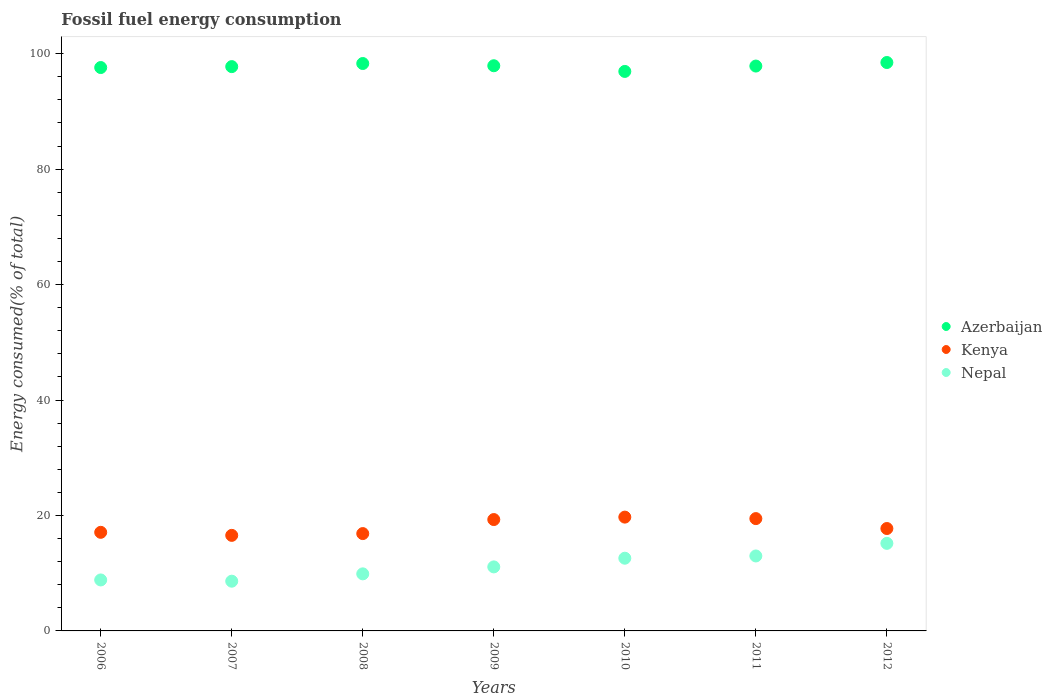Is the number of dotlines equal to the number of legend labels?
Make the answer very short. Yes. What is the percentage of energy consumed in Kenya in 2009?
Ensure brevity in your answer.  19.29. Across all years, what is the maximum percentage of energy consumed in Nepal?
Offer a terse response. 15.17. Across all years, what is the minimum percentage of energy consumed in Kenya?
Offer a very short reply. 16.55. In which year was the percentage of energy consumed in Kenya maximum?
Make the answer very short. 2010. In which year was the percentage of energy consumed in Azerbaijan minimum?
Your answer should be compact. 2010. What is the total percentage of energy consumed in Azerbaijan in the graph?
Ensure brevity in your answer.  684.86. What is the difference between the percentage of energy consumed in Kenya in 2006 and that in 2012?
Ensure brevity in your answer.  -0.66. What is the difference between the percentage of energy consumed in Nepal in 2008 and the percentage of energy consumed in Kenya in 2009?
Offer a very short reply. -9.41. What is the average percentage of energy consumed in Kenya per year?
Your answer should be compact. 18.1. In the year 2006, what is the difference between the percentage of energy consumed in Nepal and percentage of energy consumed in Kenya?
Offer a terse response. -8.25. What is the ratio of the percentage of energy consumed in Nepal in 2010 to that in 2011?
Offer a terse response. 0.97. Is the percentage of energy consumed in Azerbaijan in 2007 less than that in 2012?
Your answer should be compact. Yes. Is the difference between the percentage of energy consumed in Nepal in 2010 and 2012 greater than the difference between the percentage of energy consumed in Kenya in 2010 and 2012?
Your answer should be very brief. No. What is the difference between the highest and the second highest percentage of energy consumed in Azerbaijan?
Offer a very short reply. 0.17. What is the difference between the highest and the lowest percentage of energy consumed in Nepal?
Make the answer very short. 6.56. In how many years, is the percentage of energy consumed in Kenya greater than the average percentage of energy consumed in Kenya taken over all years?
Make the answer very short. 3. Is the sum of the percentage of energy consumed in Azerbaijan in 2008 and 2010 greater than the maximum percentage of energy consumed in Kenya across all years?
Your response must be concise. Yes. Is it the case that in every year, the sum of the percentage of energy consumed in Azerbaijan and percentage of energy consumed in Nepal  is greater than the percentage of energy consumed in Kenya?
Provide a short and direct response. Yes. Is the percentage of energy consumed in Azerbaijan strictly less than the percentage of energy consumed in Kenya over the years?
Keep it short and to the point. No. How many years are there in the graph?
Offer a terse response. 7. Does the graph contain grids?
Your response must be concise. No. How are the legend labels stacked?
Provide a succinct answer. Vertical. What is the title of the graph?
Your answer should be very brief. Fossil fuel energy consumption. Does "Benin" appear as one of the legend labels in the graph?
Offer a terse response. No. What is the label or title of the Y-axis?
Your answer should be very brief. Energy consumed(% of total). What is the Energy consumed(% of total) in Azerbaijan in 2006?
Offer a terse response. 97.61. What is the Energy consumed(% of total) in Kenya in 2006?
Offer a very short reply. 17.08. What is the Energy consumed(% of total) in Nepal in 2006?
Your answer should be very brief. 8.83. What is the Energy consumed(% of total) of Azerbaijan in 2007?
Your response must be concise. 97.76. What is the Energy consumed(% of total) of Kenya in 2007?
Provide a succinct answer. 16.55. What is the Energy consumed(% of total) of Nepal in 2007?
Offer a terse response. 8.62. What is the Energy consumed(% of total) of Azerbaijan in 2008?
Your response must be concise. 98.3. What is the Energy consumed(% of total) of Kenya in 2008?
Keep it short and to the point. 16.86. What is the Energy consumed(% of total) in Nepal in 2008?
Your response must be concise. 9.89. What is the Energy consumed(% of total) in Azerbaijan in 2009?
Ensure brevity in your answer.  97.92. What is the Energy consumed(% of total) of Kenya in 2009?
Provide a succinct answer. 19.29. What is the Energy consumed(% of total) in Nepal in 2009?
Your answer should be very brief. 11.09. What is the Energy consumed(% of total) of Azerbaijan in 2010?
Provide a succinct answer. 96.93. What is the Energy consumed(% of total) of Kenya in 2010?
Offer a very short reply. 19.72. What is the Energy consumed(% of total) in Nepal in 2010?
Keep it short and to the point. 12.6. What is the Energy consumed(% of total) of Azerbaijan in 2011?
Make the answer very short. 97.86. What is the Energy consumed(% of total) of Kenya in 2011?
Your answer should be very brief. 19.46. What is the Energy consumed(% of total) of Nepal in 2011?
Keep it short and to the point. 12.99. What is the Energy consumed(% of total) of Azerbaijan in 2012?
Provide a short and direct response. 98.48. What is the Energy consumed(% of total) in Kenya in 2012?
Offer a very short reply. 17.74. What is the Energy consumed(% of total) in Nepal in 2012?
Keep it short and to the point. 15.17. Across all years, what is the maximum Energy consumed(% of total) of Azerbaijan?
Keep it short and to the point. 98.48. Across all years, what is the maximum Energy consumed(% of total) of Kenya?
Your response must be concise. 19.72. Across all years, what is the maximum Energy consumed(% of total) in Nepal?
Offer a terse response. 15.17. Across all years, what is the minimum Energy consumed(% of total) in Azerbaijan?
Ensure brevity in your answer.  96.93. Across all years, what is the minimum Energy consumed(% of total) in Kenya?
Offer a terse response. 16.55. Across all years, what is the minimum Energy consumed(% of total) of Nepal?
Give a very brief answer. 8.62. What is the total Energy consumed(% of total) in Azerbaijan in the graph?
Provide a short and direct response. 684.86. What is the total Energy consumed(% of total) in Kenya in the graph?
Keep it short and to the point. 126.71. What is the total Energy consumed(% of total) in Nepal in the graph?
Give a very brief answer. 79.18. What is the difference between the Energy consumed(% of total) in Azerbaijan in 2006 and that in 2007?
Make the answer very short. -0.16. What is the difference between the Energy consumed(% of total) in Kenya in 2006 and that in 2007?
Make the answer very short. 0.53. What is the difference between the Energy consumed(% of total) in Nepal in 2006 and that in 2007?
Keep it short and to the point. 0.22. What is the difference between the Energy consumed(% of total) of Azerbaijan in 2006 and that in 2008?
Offer a very short reply. -0.7. What is the difference between the Energy consumed(% of total) of Kenya in 2006 and that in 2008?
Offer a very short reply. 0.22. What is the difference between the Energy consumed(% of total) of Nepal in 2006 and that in 2008?
Ensure brevity in your answer.  -1.05. What is the difference between the Energy consumed(% of total) in Azerbaijan in 2006 and that in 2009?
Keep it short and to the point. -0.31. What is the difference between the Energy consumed(% of total) of Kenya in 2006 and that in 2009?
Your response must be concise. -2.21. What is the difference between the Energy consumed(% of total) of Nepal in 2006 and that in 2009?
Give a very brief answer. -2.26. What is the difference between the Energy consumed(% of total) in Azerbaijan in 2006 and that in 2010?
Ensure brevity in your answer.  0.67. What is the difference between the Energy consumed(% of total) of Kenya in 2006 and that in 2010?
Ensure brevity in your answer.  -2.63. What is the difference between the Energy consumed(% of total) in Nepal in 2006 and that in 2010?
Offer a terse response. -3.77. What is the difference between the Energy consumed(% of total) of Azerbaijan in 2006 and that in 2011?
Give a very brief answer. -0.26. What is the difference between the Energy consumed(% of total) of Kenya in 2006 and that in 2011?
Your answer should be very brief. -2.38. What is the difference between the Energy consumed(% of total) in Nepal in 2006 and that in 2011?
Make the answer very short. -4.16. What is the difference between the Energy consumed(% of total) in Azerbaijan in 2006 and that in 2012?
Offer a terse response. -0.87. What is the difference between the Energy consumed(% of total) in Kenya in 2006 and that in 2012?
Offer a terse response. -0.66. What is the difference between the Energy consumed(% of total) of Nepal in 2006 and that in 2012?
Offer a very short reply. -6.34. What is the difference between the Energy consumed(% of total) of Azerbaijan in 2007 and that in 2008?
Keep it short and to the point. -0.54. What is the difference between the Energy consumed(% of total) of Kenya in 2007 and that in 2008?
Offer a terse response. -0.31. What is the difference between the Energy consumed(% of total) in Nepal in 2007 and that in 2008?
Your response must be concise. -1.27. What is the difference between the Energy consumed(% of total) in Azerbaijan in 2007 and that in 2009?
Provide a short and direct response. -0.15. What is the difference between the Energy consumed(% of total) in Kenya in 2007 and that in 2009?
Your answer should be compact. -2.74. What is the difference between the Energy consumed(% of total) of Nepal in 2007 and that in 2009?
Your answer should be very brief. -2.48. What is the difference between the Energy consumed(% of total) in Azerbaijan in 2007 and that in 2010?
Keep it short and to the point. 0.83. What is the difference between the Energy consumed(% of total) in Kenya in 2007 and that in 2010?
Your response must be concise. -3.16. What is the difference between the Energy consumed(% of total) in Nepal in 2007 and that in 2010?
Provide a succinct answer. -3.98. What is the difference between the Energy consumed(% of total) in Azerbaijan in 2007 and that in 2011?
Keep it short and to the point. -0.1. What is the difference between the Energy consumed(% of total) of Kenya in 2007 and that in 2011?
Ensure brevity in your answer.  -2.91. What is the difference between the Energy consumed(% of total) of Nepal in 2007 and that in 2011?
Ensure brevity in your answer.  -4.37. What is the difference between the Energy consumed(% of total) in Azerbaijan in 2007 and that in 2012?
Offer a very short reply. -0.71. What is the difference between the Energy consumed(% of total) of Kenya in 2007 and that in 2012?
Provide a succinct answer. -1.19. What is the difference between the Energy consumed(% of total) of Nepal in 2007 and that in 2012?
Offer a terse response. -6.56. What is the difference between the Energy consumed(% of total) in Azerbaijan in 2008 and that in 2009?
Offer a very short reply. 0.39. What is the difference between the Energy consumed(% of total) of Kenya in 2008 and that in 2009?
Offer a terse response. -2.43. What is the difference between the Energy consumed(% of total) in Nepal in 2008 and that in 2009?
Offer a very short reply. -1.21. What is the difference between the Energy consumed(% of total) of Azerbaijan in 2008 and that in 2010?
Provide a short and direct response. 1.37. What is the difference between the Energy consumed(% of total) of Kenya in 2008 and that in 2010?
Keep it short and to the point. -2.85. What is the difference between the Energy consumed(% of total) in Nepal in 2008 and that in 2010?
Offer a terse response. -2.71. What is the difference between the Energy consumed(% of total) of Azerbaijan in 2008 and that in 2011?
Your answer should be very brief. 0.44. What is the difference between the Energy consumed(% of total) of Kenya in 2008 and that in 2011?
Make the answer very short. -2.6. What is the difference between the Energy consumed(% of total) in Nepal in 2008 and that in 2011?
Make the answer very short. -3.1. What is the difference between the Energy consumed(% of total) of Azerbaijan in 2008 and that in 2012?
Offer a terse response. -0.17. What is the difference between the Energy consumed(% of total) of Kenya in 2008 and that in 2012?
Offer a terse response. -0.88. What is the difference between the Energy consumed(% of total) of Nepal in 2008 and that in 2012?
Your answer should be compact. -5.28. What is the difference between the Energy consumed(% of total) of Azerbaijan in 2009 and that in 2010?
Your answer should be very brief. 0.98. What is the difference between the Energy consumed(% of total) of Kenya in 2009 and that in 2010?
Your answer should be very brief. -0.42. What is the difference between the Energy consumed(% of total) of Nepal in 2009 and that in 2010?
Offer a terse response. -1.5. What is the difference between the Energy consumed(% of total) in Azerbaijan in 2009 and that in 2011?
Offer a very short reply. 0.05. What is the difference between the Energy consumed(% of total) in Kenya in 2009 and that in 2011?
Offer a terse response. -0.16. What is the difference between the Energy consumed(% of total) in Nepal in 2009 and that in 2011?
Make the answer very short. -1.89. What is the difference between the Energy consumed(% of total) of Azerbaijan in 2009 and that in 2012?
Your response must be concise. -0.56. What is the difference between the Energy consumed(% of total) in Kenya in 2009 and that in 2012?
Provide a short and direct response. 1.55. What is the difference between the Energy consumed(% of total) in Nepal in 2009 and that in 2012?
Your answer should be compact. -4.08. What is the difference between the Energy consumed(% of total) in Azerbaijan in 2010 and that in 2011?
Your answer should be compact. -0.93. What is the difference between the Energy consumed(% of total) in Kenya in 2010 and that in 2011?
Your answer should be very brief. 0.26. What is the difference between the Energy consumed(% of total) of Nepal in 2010 and that in 2011?
Your answer should be very brief. -0.39. What is the difference between the Energy consumed(% of total) in Azerbaijan in 2010 and that in 2012?
Provide a short and direct response. -1.54. What is the difference between the Energy consumed(% of total) of Kenya in 2010 and that in 2012?
Provide a succinct answer. 1.97. What is the difference between the Energy consumed(% of total) in Nepal in 2010 and that in 2012?
Offer a terse response. -2.57. What is the difference between the Energy consumed(% of total) of Azerbaijan in 2011 and that in 2012?
Keep it short and to the point. -0.61. What is the difference between the Energy consumed(% of total) of Kenya in 2011 and that in 2012?
Provide a short and direct response. 1.72. What is the difference between the Energy consumed(% of total) of Nepal in 2011 and that in 2012?
Provide a short and direct response. -2.18. What is the difference between the Energy consumed(% of total) of Azerbaijan in 2006 and the Energy consumed(% of total) of Kenya in 2007?
Keep it short and to the point. 81.05. What is the difference between the Energy consumed(% of total) of Azerbaijan in 2006 and the Energy consumed(% of total) of Nepal in 2007?
Keep it short and to the point. 88.99. What is the difference between the Energy consumed(% of total) of Kenya in 2006 and the Energy consumed(% of total) of Nepal in 2007?
Provide a succinct answer. 8.47. What is the difference between the Energy consumed(% of total) in Azerbaijan in 2006 and the Energy consumed(% of total) in Kenya in 2008?
Your response must be concise. 80.74. What is the difference between the Energy consumed(% of total) in Azerbaijan in 2006 and the Energy consumed(% of total) in Nepal in 2008?
Keep it short and to the point. 87.72. What is the difference between the Energy consumed(% of total) in Kenya in 2006 and the Energy consumed(% of total) in Nepal in 2008?
Provide a short and direct response. 7.2. What is the difference between the Energy consumed(% of total) in Azerbaijan in 2006 and the Energy consumed(% of total) in Kenya in 2009?
Your answer should be compact. 78.31. What is the difference between the Energy consumed(% of total) of Azerbaijan in 2006 and the Energy consumed(% of total) of Nepal in 2009?
Your answer should be very brief. 86.51. What is the difference between the Energy consumed(% of total) in Kenya in 2006 and the Energy consumed(% of total) in Nepal in 2009?
Your answer should be very brief. 5.99. What is the difference between the Energy consumed(% of total) in Azerbaijan in 2006 and the Energy consumed(% of total) in Kenya in 2010?
Provide a short and direct response. 77.89. What is the difference between the Energy consumed(% of total) of Azerbaijan in 2006 and the Energy consumed(% of total) of Nepal in 2010?
Provide a succinct answer. 85.01. What is the difference between the Energy consumed(% of total) of Kenya in 2006 and the Energy consumed(% of total) of Nepal in 2010?
Give a very brief answer. 4.49. What is the difference between the Energy consumed(% of total) in Azerbaijan in 2006 and the Energy consumed(% of total) in Kenya in 2011?
Provide a short and direct response. 78.15. What is the difference between the Energy consumed(% of total) in Azerbaijan in 2006 and the Energy consumed(% of total) in Nepal in 2011?
Your answer should be very brief. 84.62. What is the difference between the Energy consumed(% of total) of Kenya in 2006 and the Energy consumed(% of total) of Nepal in 2011?
Provide a short and direct response. 4.1. What is the difference between the Energy consumed(% of total) in Azerbaijan in 2006 and the Energy consumed(% of total) in Kenya in 2012?
Provide a short and direct response. 79.86. What is the difference between the Energy consumed(% of total) in Azerbaijan in 2006 and the Energy consumed(% of total) in Nepal in 2012?
Provide a short and direct response. 82.43. What is the difference between the Energy consumed(% of total) in Kenya in 2006 and the Energy consumed(% of total) in Nepal in 2012?
Provide a short and direct response. 1.91. What is the difference between the Energy consumed(% of total) in Azerbaijan in 2007 and the Energy consumed(% of total) in Kenya in 2008?
Provide a succinct answer. 80.9. What is the difference between the Energy consumed(% of total) of Azerbaijan in 2007 and the Energy consumed(% of total) of Nepal in 2008?
Offer a terse response. 87.88. What is the difference between the Energy consumed(% of total) in Kenya in 2007 and the Energy consumed(% of total) in Nepal in 2008?
Give a very brief answer. 6.67. What is the difference between the Energy consumed(% of total) of Azerbaijan in 2007 and the Energy consumed(% of total) of Kenya in 2009?
Make the answer very short. 78.47. What is the difference between the Energy consumed(% of total) of Azerbaijan in 2007 and the Energy consumed(% of total) of Nepal in 2009?
Make the answer very short. 86.67. What is the difference between the Energy consumed(% of total) of Kenya in 2007 and the Energy consumed(% of total) of Nepal in 2009?
Your answer should be compact. 5.46. What is the difference between the Energy consumed(% of total) of Azerbaijan in 2007 and the Energy consumed(% of total) of Kenya in 2010?
Your response must be concise. 78.05. What is the difference between the Energy consumed(% of total) in Azerbaijan in 2007 and the Energy consumed(% of total) in Nepal in 2010?
Offer a terse response. 85.17. What is the difference between the Energy consumed(% of total) in Kenya in 2007 and the Energy consumed(% of total) in Nepal in 2010?
Provide a succinct answer. 3.96. What is the difference between the Energy consumed(% of total) of Azerbaijan in 2007 and the Energy consumed(% of total) of Kenya in 2011?
Your answer should be very brief. 78.31. What is the difference between the Energy consumed(% of total) of Azerbaijan in 2007 and the Energy consumed(% of total) of Nepal in 2011?
Your answer should be very brief. 84.78. What is the difference between the Energy consumed(% of total) in Kenya in 2007 and the Energy consumed(% of total) in Nepal in 2011?
Provide a short and direct response. 3.57. What is the difference between the Energy consumed(% of total) in Azerbaijan in 2007 and the Energy consumed(% of total) in Kenya in 2012?
Offer a very short reply. 80.02. What is the difference between the Energy consumed(% of total) in Azerbaijan in 2007 and the Energy consumed(% of total) in Nepal in 2012?
Your answer should be compact. 82.59. What is the difference between the Energy consumed(% of total) of Kenya in 2007 and the Energy consumed(% of total) of Nepal in 2012?
Your answer should be compact. 1.38. What is the difference between the Energy consumed(% of total) of Azerbaijan in 2008 and the Energy consumed(% of total) of Kenya in 2009?
Ensure brevity in your answer.  79.01. What is the difference between the Energy consumed(% of total) of Azerbaijan in 2008 and the Energy consumed(% of total) of Nepal in 2009?
Provide a succinct answer. 87.21. What is the difference between the Energy consumed(% of total) of Kenya in 2008 and the Energy consumed(% of total) of Nepal in 2009?
Keep it short and to the point. 5.77. What is the difference between the Energy consumed(% of total) in Azerbaijan in 2008 and the Energy consumed(% of total) in Kenya in 2010?
Keep it short and to the point. 78.59. What is the difference between the Energy consumed(% of total) of Azerbaijan in 2008 and the Energy consumed(% of total) of Nepal in 2010?
Your answer should be very brief. 85.71. What is the difference between the Energy consumed(% of total) in Kenya in 2008 and the Energy consumed(% of total) in Nepal in 2010?
Your answer should be very brief. 4.27. What is the difference between the Energy consumed(% of total) of Azerbaijan in 2008 and the Energy consumed(% of total) of Kenya in 2011?
Your answer should be very brief. 78.84. What is the difference between the Energy consumed(% of total) of Azerbaijan in 2008 and the Energy consumed(% of total) of Nepal in 2011?
Your answer should be very brief. 85.32. What is the difference between the Energy consumed(% of total) in Kenya in 2008 and the Energy consumed(% of total) in Nepal in 2011?
Keep it short and to the point. 3.88. What is the difference between the Energy consumed(% of total) of Azerbaijan in 2008 and the Energy consumed(% of total) of Kenya in 2012?
Your answer should be compact. 80.56. What is the difference between the Energy consumed(% of total) in Azerbaijan in 2008 and the Energy consumed(% of total) in Nepal in 2012?
Offer a very short reply. 83.13. What is the difference between the Energy consumed(% of total) in Kenya in 2008 and the Energy consumed(% of total) in Nepal in 2012?
Keep it short and to the point. 1.69. What is the difference between the Energy consumed(% of total) in Azerbaijan in 2009 and the Energy consumed(% of total) in Kenya in 2010?
Your answer should be very brief. 78.2. What is the difference between the Energy consumed(% of total) in Azerbaijan in 2009 and the Energy consumed(% of total) in Nepal in 2010?
Give a very brief answer. 85.32. What is the difference between the Energy consumed(% of total) in Kenya in 2009 and the Energy consumed(% of total) in Nepal in 2010?
Your answer should be very brief. 6.7. What is the difference between the Energy consumed(% of total) of Azerbaijan in 2009 and the Energy consumed(% of total) of Kenya in 2011?
Your answer should be very brief. 78.46. What is the difference between the Energy consumed(% of total) in Azerbaijan in 2009 and the Energy consumed(% of total) in Nepal in 2011?
Ensure brevity in your answer.  84.93. What is the difference between the Energy consumed(% of total) in Kenya in 2009 and the Energy consumed(% of total) in Nepal in 2011?
Keep it short and to the point. 6.31. What is the difference between the Energy consumed(% of total) of Azerbaijan in 2009 and the Energy consumed(% of total) of Kenya in 2012?
Your answer should be compact. 80.17. What is the difference between the Energy consumed(% of total) of Azerbaijan in 2009 and the Energy consumed(% of total) of Nepal in 2012?
Keep it short and to the point. 82.75. What is the difference between the Energy consumed(% of total) in Kenya in 2009 and the Energy consumed(% of total) in Nepal in 2012?
Provide a short and direct response. 4.12. What is the difference between the Energy consumed(% of total) of Azerbaijan in 2010 and the Energy consumed(% of total) of Kenya in 2011?
Offer a very short reply. 77.47. What is the difference between the Energy consumed(% of total) of Azerbaijan in 2010 and the Energy consumed(% of total) of Nepal in 2011?
Provide a succinct answer. 83.95. What is the difference between the Energy consumed(% of total) in Kenya in 2010 and the Energy consumed(% of total) in Nepal in 2011?
Your answer should be compact. 6.73. What is the difference between the Energy consumed(% of total) of Azerbaijan in 2010 and the Energy consumed(% of total) of Kenya in 2012?
Keep it short and to the point. 79.19. What is the difference between the Energy consumed(% of total) in Azerbaijan in 2010 and the Energy consumed(% of total) in Nepal in 2012?
Give a very brief answer. 81.76. What is the difference between the Energy consumed(% of total) in Kenya in 2010 and the Energy consumed(% of total) in Nepal in 2012?
Your answer should be very brief. 4.55. What is the difference between the Energy consumed(% of total) of Azerbaijan in 2011 and the Energy consumed(% of total) of Kenya in 2012?
Your answer should be very brief. 80.12. What is the difference between the Energy consumed(% of total) of Azerbaijan in 2011 and the Energy consumed(% of total) of Nepal in 2012?
Provide a succinct answer. 82.69. What is the difference between the Energy consumed(% of total) in Kenya in 2011 and the Energy consumed(% of total) in Nepal in 2012?
Offer a very short reply. 4.29. What is the average Energy consumed(% of total) of Azerbaijan per year?
Give a very brief answer. 97.84. What is the average Energy consumed(% of total) of Kenya per year?
Keep it short and to the point. 18.1. What is the average Energy consumed(% of total) of Nepal per year?
Offer a very short reply. 11.31. In the year 2006, what is the difference between the Energy consumed(% of total) in Azerbaijan and Energy consumed(% of total) in Kenya?
Your answer should be very brief. 80.52. In the year 2006, what is the difference between the Energy consumed(% of total) of Azerbaijan and Energy consumed(% of total) of Nepal?
Give a very brief answer. 88.77. In the year 2006, what is the difference between the Energy consumed(% of total) in Kenya and Energy consumed(% of total) in Nepal?
Provide a short and direct response. 8.25. In the year 2007, what is the difference between the Energy consumed(% of total) of Azerbaijan and Energy consumed(% of total) of Kenya?
Give a very brief answer. 81.21. In the year 2007, what is the difference between the Energy consumed(% of total) in Azerbaijan and Energy consumed(% of total) in Nepal?
Make the answer very short. 89.15. In the year 2007, what is the difference between the Energy consumed(% of total) of Kenya and Energy consumed(% of total) of Nepal?
Provide a succinct answer. 7.94. In the year 2008, what is the difference between the Energy consumed(% of total) in Azerbaijan and Energy consumed(% of total) in Kenya?
Keep it short and to the point. 81.44. In the year 2008, what is the difference between the Energy consumed(% of total) in Azerbaijan and Energy consumed(% of total) in Nepal?
Your answer should be compact. 88.42. In the year 2008, what is the difference between the Energy consumed(% of total) in Kenya and Energy consumed(% of total) in Nepal?
Give a very brief answer. 6.98. In the year 2009, what is the difference between the Energy consumed(% of total) of Azerbaijan and Energy consumed(% of total) of Kenya?
Provide a short and direct response. 78.62. In the year 2009, what is the difference between the Energy consumed(% of total) of Azerbaijan and Energy consumed(% of total) of Nepal?
Your response must be concise. 86.82. In the year 2009, what is the difference between the Energy consumed(% of total) of Kenya and Energy consumed(% of total) of Nepal?
Your response must be concise. 8.2. In the year 2010, what is the difference between the Energy consumed(% of total) of Azerbaijan and Energy consumed(% of total) of Kenya?
Offer a very short reply. 77.22. In the year 2010, what is the difference between the Energy consumed(% of total) in Azerbaijan and Energy consumed(% of total) in Nepal?
Your answer should be very brief. 84.34. In the year 2010, what is the difference between the Energy consumed(% of total) of Kenya and Energy consumed(% of total) of Nepal?
Your answer should be very brief. 7.12. In the year 2011, what is the difference between the Energy consumed(% of total) in Azerbaijan and Energy consumed(% of total) in Kenya?
Your answer should be very brief. 78.4. In the year 2011, what is the difference between the Energy consumed(% of total) in Azerbaijan and Energy consumed(% of total) in Nepal?
Your answer should be compact. 84.88. In the year 2011, what is the difference between the Energy consumed(% of total) of Kenya and Energy consumed(% of total) of Nepal?
Ensure brevity in your answer.  6.47. In the year 2012, what is the difference between the Energy consumed(% of total) of Azerbaijan and Energy consumed(% of total) of Kenya?
Your answer should be compact. 80.74. In the year 2012, what is the difference between the Energy consumed(% of total) in Azerbaijan and Energy consumed(% of total) in Nepal?
Your answer should be very brief. 83.31. In the year 2012, what is the difference between the Energy consumed(% of total) of Kenya and Energy consumed(% of total) of Nepal?
Your answer should be compact. 2.57. What is the ratio of the Energy consumed(% of total) in Azerbaijan in 2006 to that in 2007?
Ensure brevity in your answer.  1. What is the ratio of the Energy consumed(% of total) of Kenya in 2006 to that in 2007?
Keep it short and to the point. 1.03. What is the ratio of the Energy consumed(% of total) of Nepal in 2006 to that in 2007?
Your answer should be very brief. 1.02. What is the ratio of the Energy consumed(% of total) of Nepal in 2006 to that in 2008?
Ensure brevity in your answer.  0.89. What is the ratio of the Energy consumed(% of total) of Azerbaijan in 2006 to that in 2009?
Keep it short and to the point. 1. What is the ratio of the Energy consumed(% of total) of Kenya in 2006 to that in 2009?
Keep it short and to the point. 0.89. What is the ratio of the Energy consumed(% of total) of Nepal in 2006 to that in 2009?
Offer a very short reply. 0.8. What is the ratio of the Energy consumed(% of total) in Azerbaijan in 2006 to that in 2010?
Provide a short and direct response. 1.01. What is the ratio of the Energy consumed(% of total) in Kenya in 2006 to that in 2010?
Your answer should be compact. 0.87. What is the ratio of the Energy consumed(% of total) in Nepal in 2006 to that in 2010?
Give a very brief answer. 0.7. What is the ratio of the Energy consumed(% of total) of Azerbaijan in 2006 to that in 2011?
Provide a short and direct response. 1. What is the ratio of the Energy consumed(% of total) of Kenya in 2006 to that in 2011?
Make the answer very short. 0.88. What is the ratio of the Energy consumed(% of total) of Nepal in 2006 to that in 2011?
Make the answer very short. 0.68. What is the ratio of the Energy consumed(% of total) of Kenya in 2006 to that in 2012?
Keep it short and to the point. 0.96. What is the ratio of the Energy consumed(% of total) of Nepal in 2006 to that in 2012?
Give a very brief answer. 0.58. What is the ratio of the Energy consumed(% of total) in Azerbaijan in 2007 to that in 2008?
Offer a terse response. 0.99. What is the ratio of the Energy consumed(% of total) in Kenya in 2007 to that in 2008?
Provide a short and direct response. 0.98. What is the ratio of the Energy consumed(% of total) of Nepal in 2007 to that in 2008?
Keep it short and to the point. 0.87. What is the ratio of the Energy consumed(% of total) in Azerbaijan in 2007 to that in 2009?
Your answer should be compact. 1. What is the ratio of the Energy consumed(% of total) in Kenya in 2007 to that in 2009?
Keep it short and to the point. 0.86. What is the ratio of the Energy consumed(% of total) in Nepal in 2007 to that in 2009?
Offer a terse response. 0.78. What is the ratio of the Energy consumed(% of total) in Azerbaijan in 2007 to that in 2010?
Provide a succinct answer. 1.01. What is the ratio of the Energy consumed(% of total) in Kenya in 2007 to that in 2010?
Provide a short and direct response. 0.84. What is the ratio of the Energy consumed(% of total) of Nepal in 2007 to that in 2010?
Offer a very short reply. 0.68. What is the ratio of the Energy consumed(% of total) in Kenya in 2007 to that in 2011?
Ensure brevity in your answer.  0.85. What is the ratio of the Energy consumed(% of total) of Nepal in 2007 to that in 2011?
Provide a short and direct response. 0.66. What is the ratio of the Energy consumed(% of total) in Azerbaijan in 2007 to that in 2012?
Provide a succinct answer. 0.99. What is the ratio of the Energy consumed(% of total) in Kenya in 2007 to that in 2012?
Your answer should be compact. 0.93. What is the ratio of the Energy consumed(% of total) of Nepal in 2007 to that in 2012?
Give a very brief answer. 0.57. What is the ratio of the Energy consumed(% of total) in Kenya in 2008 to that in 2009?
Your response must be concise. 0.87. What is the ratio of the Energy consumed(% of total) in Nepal in 2008 to that in 2009?
Your answer should be very brief. 0.89. What is the ratio of the Energy consumed(% of total) in Azerbaijan in 2008 to that in 2010?
Your response must be concise. 1.01. What is the ratio of the Energy consumed(% of total) of Kenya in 2008 to that in 2010?
Keep it short and to the point. 0.86. What is the ratio of the Energy consumed(% of total) of Nepal in 2008 to that in 2010?
Provide a succinct answer. 0.78. What is the ratio of the Energy consumed(% of total) of Kenya in 2008 to that in 2011?
Offer a very short reply. 0.87. What is the ratio of the Energy consumed(% of total) in Nepal in 2008 to that in 2011?
Make the answer very short. 0.76. What is the ratio of the Energy consumed(% of total) of Kenya in 2008 to that in 2012?
Make the answer very short. 0.95. What is the ratio of the Energy consumed(% of total) in Nepal in 2008 to that in 2012?
Your answer should be compact. 0.65. What is the ratio of the Energy consumed(% of total) in Azerbaijan in 2009 to that in 2010?
Your answer should be compact. 1.01. What is the ratio of the Energy consumed(% of total) in Kenya in 2009 to that in 2010?
Your response must be concise. 0.98. What is the ratio of the Energy consumed(% of total) of Nepal in 2009 to that in 2010?
Your answer should be very brief. 0.88. What is the ratio of the Energy consumed(% of total) in Kenya in 2009 to that in 2011?
Ensure brevity in your answer.  0.99. What is the ratio of the Energy consumed(% of total) of Nepal in 2009 to that in 2011?
Ensure brevity in your answer.  0.85. What is the ratio of the Energy consumed(% of total) of Azerbaijan in 2009 to that in 2012?
Ensure brevity in your answer.  0.99. What is the ratio of the Energy consumed(% of total) of Kenya in 2009 to that in 2012?
Your answer should be compact. 1.09. What is the ratio of the Energy consumed(% of total) of Nepal in 2009 to that in 2012?
Your response must be concise. 0.73. What is the ratio of the Energy consumed(% of total) in Azerbaijan in 2010 to that in 2011?
Provide a succinct answer. 0.99. What is the ratio of the Energy consumed(% of total) in Kenya in 2010 to that in 2011?
Offer a terse response. 1.01. What is the ratio of the Energy consumed(% of total) in Nepal in 2010 to that in 2011?
Your response must be concise. 0.97. What is the ratio of the Energy consumed(% of total) in Azerbaijan in 2010 to that in 2012?
Your answer should be very brief. 0.98. What is the ratio of the Energy consumed(% of total) in Kenya in 2010 to that in 2012?
Your response must be concise. 1.11. What is the ratio of the Energy consumed(% of total) in Nepal in 2010 to that in 2012?
Give a very brief answer. 0.83. What is the ratio of the Energy consumed(% of total) of Azerbaijan in 2011 to that in 2012?
Provide a succinct answer. 0.99. What is the ratio of the Energy consumed(% of total) of Kenya in 2011 to that in 2012?
Keep it short and to the point. 1.1. What is the ratio of the Energy consumed(% of total) of Nepal in 2011 to that in 2012?
Your response must be concise. 0.86. What is the difference between the highest and the second highest Energy consumed(% of total) in Azerbaijan?
Ensure brevity in your answer.  0.17. What is the difference between the highest and the second highest Energy consumed(% of total) in Kenya?
Give a very brief answer. 0.26. What is the difference between the highest and the second highest Energy consumed(% of total) in Nepal?
Offer a very short reply. 2.18. What is the difference between the highest and the lowest Energy consumed(% of total) in Azerbaijan?
Your answer should be compact. 1.54. What is the difference between the highest and the lowest Energy consumed(% of total) of Kenya?
Your answer should be compact. 3.16. What is the difference between the highest and the lowest Energy consumed(% of total) in Nepal?
Provide a short and direct response. 6.56. 